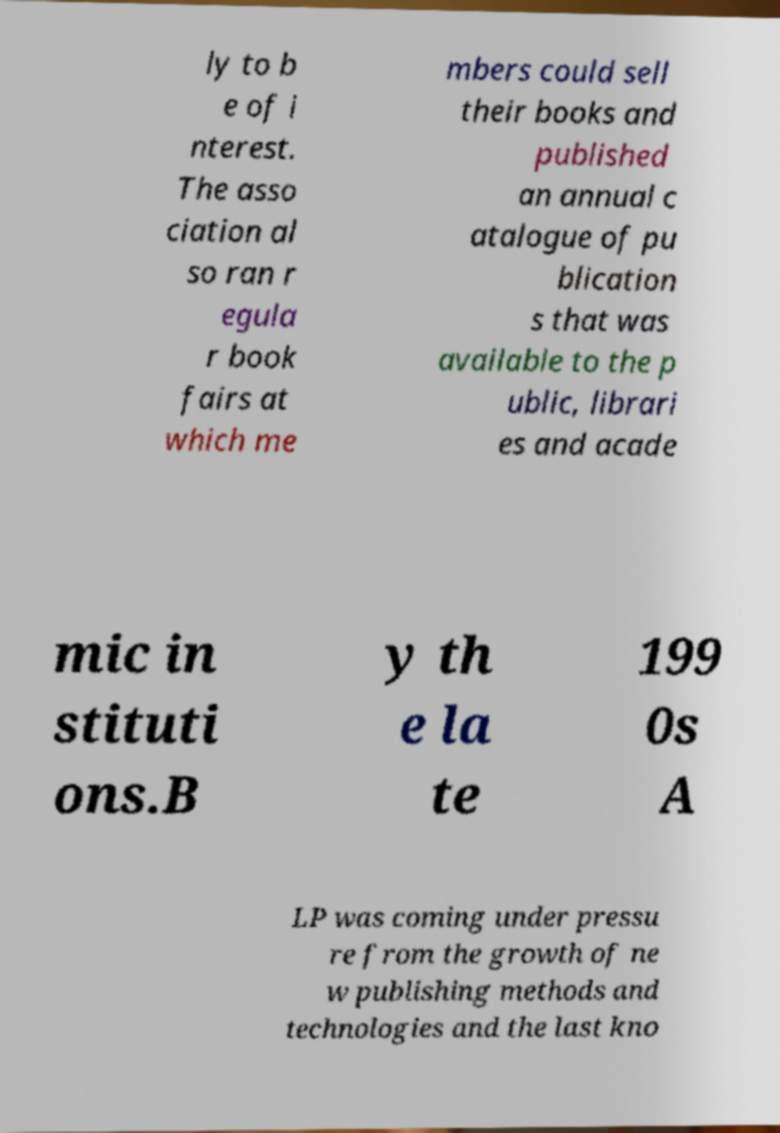Please read and relay the text visible in this image. What does it say? ly to b e of i nterest. The asso ciation al so ran r egula r book fairs at which me mbers could sell their books and published an annual c atalogue of pu blication s that was available to the p ublic, librari es and acade mic in stituti ons.B y th e la te 199 0s A LP was coming under pressu re from the growth of ne w publishing methods and technologies and the last kno 